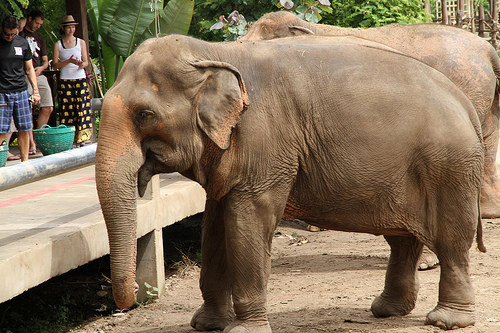Who wears a t-shirt? The man in the image is wearing a t-shirt. 